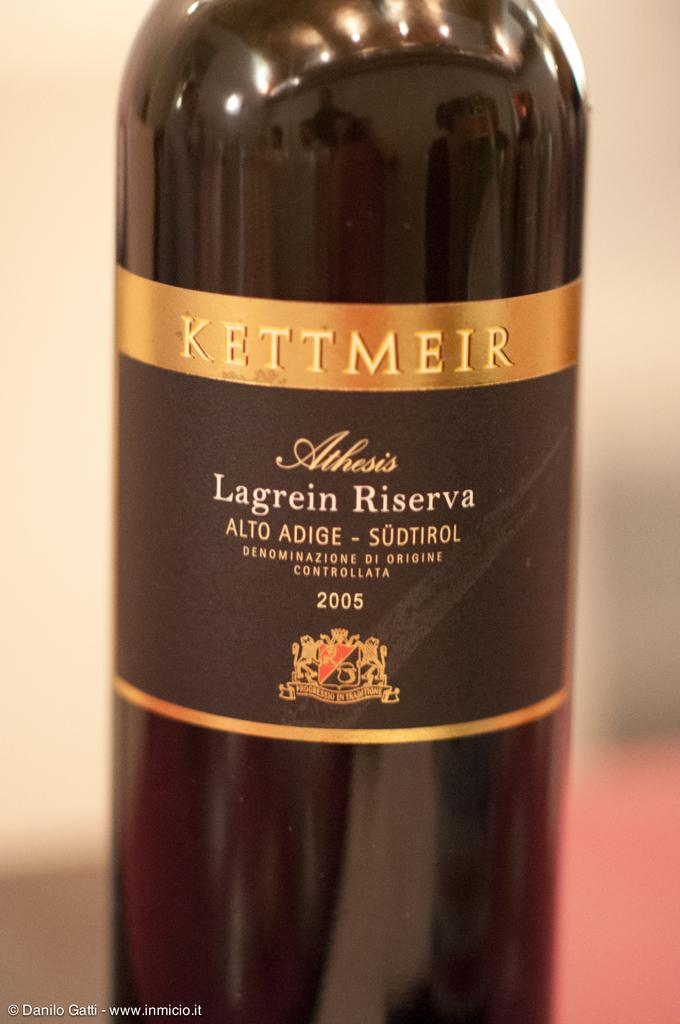<image>
Give a short and clear explanation of the subsequent image. A bottle that is dated 2005 has the Kettmeir logo on it. 